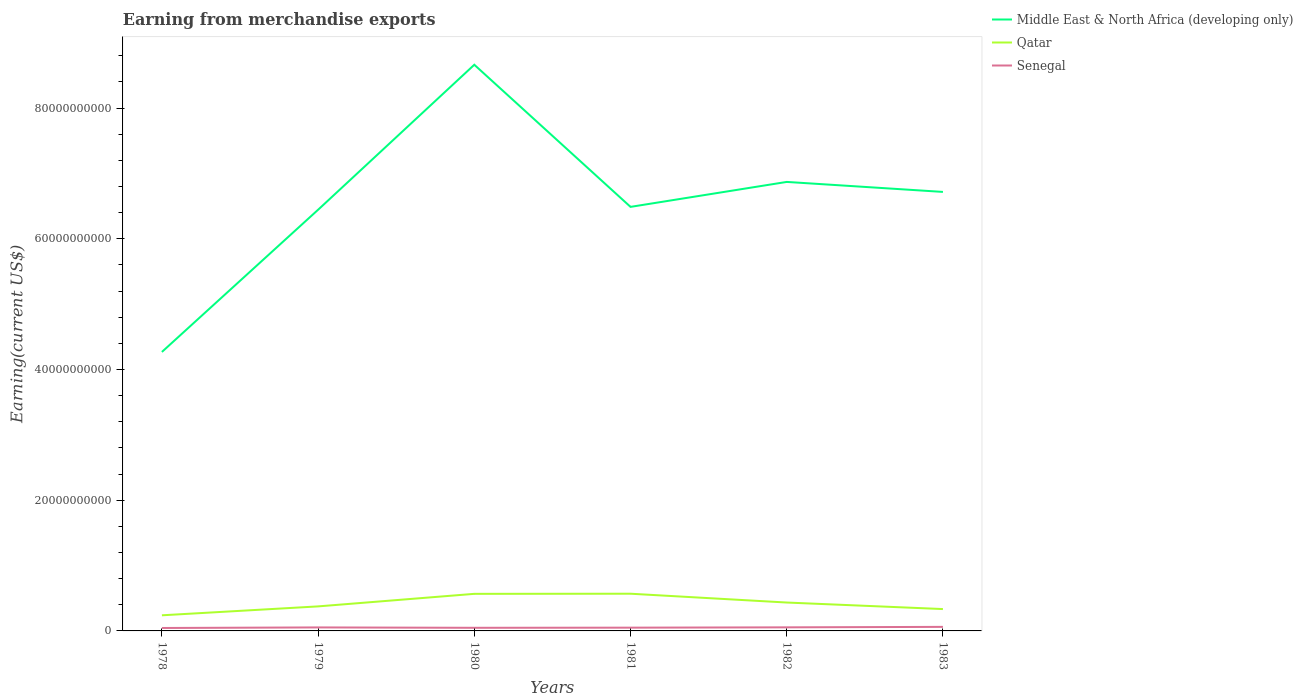How many different coloured lines are there?
Provide a succinct answer. 3. Across all years, what is the maximum amount earned from merchandise exports in Senegal?
Your response must be concise. 4.49e+08. In which year was the amount earned from merchandise exports in Qatar maximum?
Give a very brief answer. 1978. What is the total amount earned from merchandise exports in Qatar in the graph?
Make the answer very short. 9.98e+08. What is the difference between the highest and the second highest amount earned from merchandise exports in Middle East & North Africa (developing only)?
Offer a very short reply. 4.39e+1. How many years are there in the graph?
Make the answer very short. 6. Does the graph contain grids?
Your answer should be very brief. No. How many legend labels are there?
Offer a terse response. 3. What is the title of the graph?
Your response must be concise. Earning from merchandise exports. Does "Comoros" appear as one of the legend labels in the graph?
Keep it short and to the point. No. What is the label or title of the X-axis?
Offer a terse response. Years. What is the label or title of the Y-axis?
Give a very brief answer. Earning(current US$). What is the Earning(current US$) in Middle East & North Africa (developing only) in 1978?
Provide a succinct answer. 4.27e+1. What is the Earning(current US$) of Qatar in 1978?
Your answer should be compact. 2.39e+09. What is the Earning(current US$) in Senegal in 1978?
Your answer should be compact. 4.49e+08. What is the Earning(current US$) of Middle East & North Africa (developing only) in 1979?
Provide a succinct answer. 6.44e+1. What is the Earning(current US$) in Qatar in 1979?
Provide a short and direct response. 3.75e+09. What is the Earning(current US$) of Senegal in 1979?
Offer a very short reply. 5.35e+08. What is the Earning(current US$) of Middle East & North Africa (developing only) in 1980?
Your answer should be very brief. 8.66e+1. What is the Earning(current US$) in Qatar in 1980?
Ensure brevity in your answer.  5.67e+09. What is the Earning(current US$) of Senegal in 1980?
Give a very brief answer. 4.77e+08. What is the Earning(current US$) in Middle East & North Africa (developing only) in 1981?
Make the answer very short. 6.49e+1. What is the Earning(current US$) of Qatar in 1981?
Provide a succinct answer. 5.69e+09. What is the Earning(current US$) of Senegal in 1981?
Keep it short and to the point. 5.00e+08. What is the Earning(current US$) of Middle East & North Africa (developing only) in 1982?
Provide a short and direct response. 6.87e+1. What is the Earning(current US$) in Qatar in 1982?
Offer a terse response. 4.34e+09. What is the Earning(current US$) in Senegal in 1982?
Offer a terse response. 5.48e+08. What is the Earning(current US$) of Middle East & North Africa (developing only) in 1983?
Offer a terse response. 6.72e+1. What is the Earning(current US$) of Qatar in 1983?
Your response must be concise. 3.34e+09. What is the Earning(current US$) in Senegal in 1983?
Ensure brevity in your answer.  6.18e+08. Across all years, what is the maximum Earning(current US$) in Middle East & North Africa (developing only)?
Your answer should be very brief. 8.66e+1. Across all years, what is the maximum Earning(current US$) of Qatar?
Ensure brevity in your answer.  5.69e+09. Across all years, what is the maximum Earning(current US$) in Senegal?
Your answer should be very brief. 6.18e+08. Across all years, what is the minimum Earning(current US$) in Middle East & North Africa (developing only)?
Give a very brief answer. 4.27e+1. Across all years, what is the minimum Earning(current US$) of Qatar?
Provide a short and direct response. 2.39e+09. Across all years, what is the minimum Earning(current US$) of Senegal?
Provide a short and direct response. 4.49e+08. What is the total Earning(current US$) in Middle East & North Africa (developing only) in the graph?
Offer a very short reply. 3.94e+11. What is the total Earning(current US$) of Qatar in the graph?
Make the answer very short. 2.52e+1. What is the total Earning(current US$) in Senegal in the graph?
Your answer should be compact. 3.13e+09. What is the difference between the Earning(current US$) of Middle East & North Africa (developing only) in 1978 and that in 1979?
Keep it short and to the point. -2.18e+1. What is the difference between the Earning(current US$) of Qatar in 1978 and that in 1979?
Keep it short and to the point. -1.36e+09. What is the difference between the Earning(current US$) in Senegal in 1978 and that in 1979?
Provide a succinct answer. -8.59e+07. What is the difference between the Earning(current US$) in Middle East & North Africa (developing only) in 1978 and that in 1980?
Your response must be concise. -4.39e+1. What is the difference between the Earning(current US$) of Qatar in 1978 and that in 1980?
Your answer should be very brief. -3.28e+09. What is the difference between the Earning(current US$) in Senegal in 1978 and that in 1980?
Make the answer very short. -2.76e+07. What is the difference between the Earning(current US$) of Middle East & North Africa (developing only) in 1978 and that in 1981?
Keep it short and to the point. -2.22e+1. What is the difference between the Earning(current US$) of Qatar in 1978 and that in 1981?
Offer a terse response. -3.30e+09. What is the difference between the Earning(current US$) in Senegal in 1978 and that in 1981?
Give a very brief answer. -5.06e+07. What is the difference between the Earning(current US$) of Middle East & North Africa (developing only) in 1978 and that in 1982?
Give a very brief answer. -2.60e+1. What is the difference between the Earning(current US$) of Qatar in 1978 and that in 1982?
Your answer should be compact. -1.95e+09. What is the difference between the Earning(current US$) in Senegal in 1978 and that in 1982?
Offer a very short reply. -9.86e+07. What is the difference between the Earning(current US$) in Middle East & North Africa (developing only) in 1978 and that in 1983?
Make the answer very short. -2.45e+1. What is the difference between the Earning(current US$) of Qatar in 1978 and that in 1983?
Offer a terse response. -9.54e+08. What is the difference between the Earning(current US$) in Senegal in 1978 and that in 1983?
Your answer should be compact. -1.69e+08. What is the difference between the Earning(current US$) of Middle East & North Africa (developing only) in 1979 and that in 1980?
Offer a terse response. -2.22e+1. What is the difference between the Earning(current US$) in Qatar in 1979 and that in 1980?
Provide a short and direct response. -1.92e+09. What is the difference between the Earning(current US$) in Senegal in 1979 and that in 1980?
Give a very brief answer. 5.83e+07. What is the difference between the Earning(current US$) in Middle East & North Africa (developing only) in 1979 and that in 1981?
Offer a very short reply. -4.37e+08. What is the difference between the Earning(current US$) of Qatar in 1979 and that in 1981?
Ensure brevity in your answer.  -1.94e+09. What is the difference between the Earning(current US$) in Senegal in 1979 and that in 1981?
Provide a succinct answer. 3.53e+07. What is the difference between the Earning(current US$) in Middle East & North Africa (developing only) in 1979 and that in 1982?
Offer a very short reply. -4.26e+09. What is the difference between the Earning(current US$) in Qatar in 1979 and that in 1982?
Provide a short and direct response. -5.90e+08. What is the difference between the Earning(current US$) of Senegal in 1979 and that in 1982?
Make the answer very short. -1.27e+07. What is the difference between the Earning(current US$) of Middle East & North Africa (developing only) in 1979 and that in 1983?
Your answer should be very brief. -2.73e+09. What is the difference between the Earning(current US$) of Qatar in 1979 and that in 1983?
Keep it short and to the point. 4.08e+08. What is the difference between the Earning(current US$) of Senegal in 1979 and that in 1983?
Provide a succinct answer. -8.27e+07. What is the difference between the Earning(current US$) of Middle East & North Africa (developing only) in 1980 and that in 1981?
Provide a short and direct response. 2.17e+1. What is the difference between the Earning(current US$) of Qatar in 1980 and that in 1981?
Give a very brief answer. -1.90e+07. What is the difference between the Earning(current US$) in Senegal in 1980 and that in 1981?
Offer a very short reply. -2.30e+07. What is the difference between the Earning(current US$) in Middle East & North Africa (developing only) in 1980 and that in 1982?
Give a very brief answer. 1.79e+1. What is the difference between the Earning(current US$) in Qatar in 1980 and that in 1982?
Give a very brief answer. 1.33e+09. What is the difference between the Earning(current US$) of Senegal in 1980 and that in 1982?
Keep it short and to the point. -7.10e+07. What is the difference between the Earning(current US$) of Middle East & North Africa (developing only) in 1980 and that in 1983?
Your answer should be compact. 1.95e+1. What is the difference between the Earning(current US$) in Qatar in 1980 and that in 1983?
Your answer should be compact. 2.33e+09. What is the difference between the Earning(current US$) in Senegal in 1980 and that in 1983?
Provide a succinct answer. -1.41e+08. What is the difference between the Earning(current US$) of Middle East & North Africa (developing only) in 1981 and that in 1982?
Provide a short and direct response. -3.82e+09. What is the difference between the Earning(current US$) of Qatar in 1981 and that in 1982?
Your answer should be very brief. 1.35e+09. What is the difference between the Earning(current US$) of Senegal in 1981 and that in 1982?
Provide a short and direct response. -4.80e+07. What is the difference between the Earning(current US$) of Middle East & North Africa (developing only) in 1981 and that in 1983?
Provide a succinct answer. -2.29e+09. What is the difference between the Earning(current US$) of Qatar in 1981 and that in 1983?
Make the answer very short. 2.35e+09. What is the difference between the Earning(current US$) of Senegal in 1981 and that in 1983?
Provide a succinct answer. -1.18e+08. What is the difference between the Earning(current US$) in Middle East & North Africa (developing only) in 1982 and that in 1983?
Ensure brevity in your answer.  1.53e+09. What is the difference between the Earning(current US$) in Qatar in 1982 and that in 1983?
Provide a succinct answer. 9.98e+08. What is the difference between the Earning(current US$) of Senegal in 1982 and that in 1983?
Your answer should be very brief. -7.00e+07. What is the difference between the Earning(current US$) of Middle East & North Africa (developing only) in 1978 and the Earning(current US$) of Qatar in 1979?
Your answer should be very brief. 3.89e+1. What is the difference between the Earning(current US$) in Middle East & North Africa (developing only) in 1978 and the Earning(current US$) in Senegal in 1979?
Provide a succinct answer. 4.21e+1. What is the difference between the Earning(current US$) in Qatar in 1978 and the Earning(current US$) in Senegal in 1979?
Keep it short and to the point. 1.86e+09. What is the difference between the Earning(current US$) in Middle East & North Africa (developing only) in 1978 and the Earning(current US$) in Qatar in 1980?
Offer a very short reply. 3.70e+1. What is the difference between the Earning(current US$) in Middle East & North Africa (developing only) in 1978 and the Earning(current US$) in Senegal in 1980?
Offer a terse response. 4.22e+1. What is the difference between the Earning(current US$) in Qatar in 1978 and the Earning(current US$) in Senegal in 1980?
Give a very brief answer. 1.91e+09. What is the difference between the Earning(current US$) of Middle East & North Africa (developing only) in 1978 and the Earning(current US$) of Qatar in 1981?
Ensure brevity in your answer.  3.70e+1. What is the difference between the Earning(current US$) of Middle East & North Africa (developing only) in 1978 and the Earning(current US$) of Senegal in 1981?
Offer a terse response. 4.22e+1. What is the difference between the Earning(current US$) in Qatar in 1978 and the Earning(current US$) in Senegal in 1981?
Provide a short and direct response. 1.89e+09. What is the difference between the Earning(current US$) of Middle East & North Africa (developing only) in 1978 and the Earning(current US$) of Qatar in 1982?
Offer a terse response. 3.83e+1. What is the difference between the Earning(current US$) of Middle East & North Africa (developing only) in 1978 and the Earning(current US$) of Senegal in 1982?
Give a very brief answer. 4.21e+1. What is the difference between the Earning(current US$) of Qatar in 1978 and the Earning(current US$) of Senegal in 1982?
Give a very brief answer. 1.84e+09. What is the difference between the Earning(current US$) of Middle East & North Africa (developing only) in 1978 and the Earning(current US$) of Qatar in 1983?
Ensure brevity in your answer.  3.93e+1. What is the difference between the Earning(current US$) in Middle East & North Africa (developing only) in 1978 and the Earning(current US$) in Senegal in 1983?
Ensure brevity in your answer.  4.21e+1. What is the difference between the Earning(current US$) of Qatar in 1978 and the Earning(current US$) of Senegal in 1983?
Offer a terse response. 1.77e+09. What is the difference between the Earning(current US$) of Middle East & North Africa (developing only) in 1979 and the Earning(current US$) of Qatar in 1980?
Keep it short and to the point. 5.88e+1. What is the difference between the Earning(current US$) in Middle East & North Africa (developing only) in 1979 and the Earning(current US$) in Senegal in 1980?
Your response must be concise. 6.40e+1. What is the difference between the Earning(current US$) in Qatar in 1979 and the Earning(current US$) in Senegal in 1980?
Offer a very short reply. 3.28e+09. What is the difference between the Earning(current US$) of Middle East & North Africa (developing only) in 1979 and the Earning(current US$) of Qatar in 1981?
Offer a terse response. 5.87e+1. What is the difference between the Earning(current US$) of Middle East & North Africa (developing only) in 1979 and the Earning(current US$) of Senegal in 1981?
Your response must be concise. 6.39e+1. What is the difference between the Earning(current US$) in Qatar in 1979 and the Earning(current US$) in Senegal in 1981?
Make the answer very short. 3.25e+09. What is the difference between the Earning(current US$) of Middle East & North Africa (developing only) in 1979 and the Earning(current US$) of Qatar in 1982?
Offer a very short reply. 6.01e+1. What is the difference between the Earning(current US$) in Middle East & North Africa (developing only) in 1979 and the Earning(current US$) in Senegal in 1982?
Offer a terse response. 6.39e+1. What is the difference between the Earning(current US$) of Qatar in 1979 and the Earning(current US$) of Senegal in 1982?
Offer a very short reply. 3.20e+09. What is the difference between the Earning(current US$) of Middle East & North Africa (developing only) in 1979 and the Earning(current US$) of Qatar in 1983?
Give a very brief answer. 6.11e+1. What is the difference between the Earning(current US$) of Middle East & North Africa (developing only) in 1979 and the Earning(current US$) of Senegal in 1983?
Your answer should be compact. 6.38e+1. What is the difference between the Earning(current US$) in Qatar in 1979 and the Earning(current US$) in Senegal in 1983?
Offer a terse response. 3.13e+09. What is the difference between the Earning(current US$) in Middle East & North Africa (developing only) in 1980 and the Earning(current US$) in Qatar in 1981?
Ensure brevity in your answer.  8.09e+1. What is the difference between the Earning(current US$) in Middle East & North Africa (developing only) in 1980 and the Earning(current US$) in Senegal in 1981?
Give a very brief answer. 8.61e+1. What is the difference between the Earning(current US$) in Qatar in 1980 and the Earning(current US$) in Senegal in 1981?
Your answer should be very brief. 5.17e+09. What is the difference between the Earning(current US$) of Middle East & North Africa (developing only) in 1980 and the Earning(current US$) of Qatar in 1982?
Provide a succinct answer. 8.23e+1. What is the difference between the Earning(current US$) of Middle East & North Africa (developing only) in 1980 and the Earning(current US$) of Senegal in 1982?
Your answer should be compact. 8.61e+1. What is the difference between the Earning(current US$) in Qatar in 1980 and the Earning(current US$) in Senegal in 1982?
Your answer should be very brief. 5.12e+09. What is the difference between the Earning(current US$) of Middle East & North Africa (developing only) in 1980 and the Earning(current US$) of Qatar in 1983?
Keep it short and to the point. 8.33e+1. What is the difference between the Earning(current US$) in Middle East & North Africa (developing only) in 1980 and the Earning(current US$) in Senegal in 1983?
Provide a short and direct response. 8.60e+1. What is the difference between the Earning(current US$) in Qatar in 1980 and the Earning(current US$) in Senegal in 1983?
Your response must be concise. 5.05e+09. What is the difference between the Earning(current US$) in Middle East & North Africa (developing only) in 1981 and the Earning(current US$) in Qatar in 1982?
Your answer should be compact. 6.05e+1. What is the difference between the Earning(current US$) in Middle East & North Africa (developing only) in 1981 and the Earning(current US$) in Senegal in 1982?
Offer a very short reply. 6.43e+1. What is the difference between the Earning(current US$) in Qatar in 1981 and the Earning(current US$) in Senegal in 1982?
Your answer should be compact. 5.14e+09. What is the difference between the Earning(current US$) in Middle East & North Africa (developing only) in 1981 and the Earning(current US$) in Qatar in 1983?
Keep it short and to the point. 6.15e+1. What is the difference between the Earning(current US$) in Middle East & North Africa (developing only) in 1981 and the Earning(current US$) in Senegal in 1983?
Keep it short and to the point. 6.43e+1. What is the difference between the Earning(current US$) in Qatar in 1981 and the Earning(current US$) in Senegal in 1983?
Offer a very short reply. 5.07e+09. What is the difference between the Earning(current US$) in Middle East & North Africa (developing only) in 1982 and the Earning(current US$) in Qatar in 1983?
Provide a succinct answer. 6.53e+1. What is the difference between the Earning(current US$) in Middle East & North Africa (developing only) in 1982 and the Earning(current US$) in Senegal in 1983?
Keep it short and to the point. 6.81e+1. What is the difference between the Earning(current US$) in Qatar in 1982 and the Earning(current US$) in Senegal in 1983?
Your response must be concise. 3.72e+09. What is the average Earning(current US$) in Middle East & North Africa (developing only) per year?
Your response must be concise. 6.57e+1. What is the average Earning(current US$) in Qatar per year?
Provide a succinct answer. 4.20e+09. What is the average Earning(current US$) in Senegal per year?
Keep it short and to the point. 5.21e+08. In the year 1978, what is the difference between the Earning(current US$) of Middle East & North Africa (developing only) and Earning(current US$) of Qatar?
Offer a terse response. 4.03e+1. In the year 1978, what is the difference between the Earning(current US$) of Middle East & North Africa (developing only) and Earning(current US$) of Senegal?
Your answer should be very brief. 4.22e+1. In the year 1978, what is the difference between the Earning(current US$) of Qatar and Earning(current US$) of Senegal?
Offer a very short reply. 1.94e+09. In the year 1979, what is the difference between the Earning(current US$) of Middle East & North Africa (developing only) and Earning(current US$) of Qatar?
Offer a very short reply. 6.07e+1. In the year 1979, what is the difference between the Earning(current US$) of Middle East & North Africa (developing only) and Earning(current US$) of Senegal?
Offer a very short reply. 6.39e+1. In the year 1979, what is the difference between the Earning(current US$) in Qatar and Earning(current US$) in Senegal?
Your answer should be very brief. 3.22e+09. In the year 1980, what is the difference between the Earning(current US$) in Middle East & North Africa (developing only) and Earning(current US$) in Qatar?
Ensure brevity in your answer.  8.09e+1. In the year 1980, what is the difference between the Earning(current US$) in Middle East & North Africa (developing only) and Earning(current US$) in Senegal?
Provide a short and direct response. 8.61e+1. In the year 1980, what is the difference between the Earning(current US$) of Qatar and Earning(current US$) of Senegal?
Provide a short and direct response. 5.20e+09. In the year 1981, what is the difference between the Earning(current US$) of Middle East & North Africa (developing only) and Earning(current US$) of Qatar?
Provide a short and direct response. 5.92e+1. In the year 1981, what is the difference between the Earning(current US$) of Middle East & North Africa (developing only) and Earning(current US$) of Senegal?
Provide a short and direct response. 6.44e+1. In the year 1981, what is the difference between the Earning(current US$) of Qatar and Earning(current US$) of Senegal?
Provide a succinct answer. 5.19e+09. In the year 1982, what is the difference between the Earning(current US$) in Middle East & North Africa (developing only) and Earning(current US$) in Qatar?
Provide a succinct answer. 6.43e+1. In the year 1982, what is the difference between the Earning(current US$) in Middle East & North Africa (developing only) and Earning(current US$) in Senegal?
Your response must be concise. 6.81e+1. In the year 1982, what is the difference between the Earning(current US$) in Qatar and Earning(current US$) in Senegal?
Make the answer very short. 3.80e+09. In the year 1983, what is the difference between the Earning(current US$) in Middle East & North Africa (developing only) and Earning(current US$) in Qatar?
Provide a short and direct response. 6.38e+1. In the year 1983, what is the difference between the Earning(current US$) of Middle East & North Africa (developing only) and Earning(current US$) of Senegal?
Your answer should be very brief. 6.65e+1. In the year 1983, what is the difference between the Earning(current US$) of Qatar and Earning(current US$) of Senegal?
Offer a terse response. 2.73e+09. What is the ratio of the Earning(current US$) of Middle East & North Africa (developing only) in 1978 to that in 1979?
Offer a terse response. 0.66. What is the ratio of the Earning(current US$) of Qatar in 1978 to that in 1979?
Provide a short and direct response. 0.64. What is the ratio of the Earning(current US$) in Senegal in 1978 to that in 1979?
Your response must be concise. 0.84. What is the ratio of the Earning(current US$) in Middle East & North Africa (developing only) in 1978 to that in 1980?
Make the answer very short. 0.49. What is the ratio of the Earning(current US$) of Qatar in 1978 to that in 1980?
Ensure brevity in your answer.  0.42. What is the ratio of the Earning(current US$) in Senegal in 1978 to that in 1980?
Provide a succinct answer. 0.94. What is the ratio of the Earning(current US$) in Middle East & North Africa (developing only) in 1978 to that in 1981?
Give a very brief answer. 0.66. What is the ratio of the Earning(current US$) of Qatar in 1978 to that in 1981?
Your answer should be compact. 0.42. What is the ratio of the Earning(current US$) of Senegal in 1978 to that in 1981?
Keep it short and to the point. 0.9. What is the ratio of the Earning(current US$) in Middle East & North Africa (developing only) in 1978 to that in 1982?
Your response must be concise. 0.62. What is the ratio of the Earning(current US$) of Qatar in 1978 to that in 1982?
Keep it short and to the point. 0.55. What is the ratio of the Earning(current US$) of Senegal in 1978 to that in 1982?
Keep it short and to the point. 0.82. What is the ratio of the Earning(current US$) in Middle East & North Africa (developing only) in 1978 to that in 1983?
Provide a succinct answer. 0.64. What is the ratio of the Earning(current US$) in Qatar in 1978 to that in 1983?
Ensure brevity in your answer.  0.71. What is the ratio of the Earning(current US$) of Senegal in 1978 to that in 1983?
Keep it short and to the point. 0.73. What is the ratio of the Earning(current US$) in Middle East & North Africa (developing only) in 1979 to that in 1980?
Keep it short and to the point. 0.74. What is the ratio of the Earning(current US$) in Qatar in 1979 to that in 1980?
Offer a very short reply. 0.66. What is the ratio of the Earning(current US$) of Senegal in 1979 to that in 1980?
Offer a terse response. 1.12. What is the ratio of the Earning(current US$) in Middle East & North Africa (developing only) in 1979 to that in 1981?
Ensure brevity in your answer.  0.99. What is the ratio of the Earning(current US$) of Qatar in 1979 to that in 1981?
Provide a short and direct response. 0.66. What is the ratio of the Earning(current US$) in Senegal in 1979 to that in 1981?
Your answer should be very brief. 1.07. What is the ratio of the Earning(current US$) of Middle East & North Africa (developing only) in 1979 to that in 1982?
Give a very brief answer. 0.94. What is the ratio of the Earning(current US$) of Qatar in 1979 to that in 1982?
Offer a terse response. 0.86. What is the ratio of the Earning(current US$) of Senegal in 1979 to that in 1982?
Your response must be concise. 0.98. What is the ratio of the Earning(current US$) in Middle East & North Africa (developing only) in 1979 to that in 1983?
Ensure brevity in your answer.  0.96. What is the ratio of the Earning(current US$) of Qatar in 1979 to that in 1983?
Offer a very short reply. 1.12. What is the ratio of the Earning(current US$) of Senegal in 1979 to that in 1983?
Provide a succinct answer. 0.87. What is the ratio of the Earning(current US$) in Middle East & North Africa (developing only) in 1980 to that in 1981?
Your response must be concise. 1.34. What is the ratio of the Earning(current US$) of Qatar in 1980 to that in 1981?
Give a very brief answer. 1. What is the ratio of the Earning(current US$) of Senegal in 1980 to that in 1981?
Give a very brief answer. 0.95. What is the ratio of the Earning(current US$) of Middle East & North Africa (developing only) in 1980 to that in 1982?
Offer a very short reply. 1.26. What is the ratio of the Earning(current US$) in Qatar in 1980 to that in 1982?
Make the answer very short. 1.31. What is the ratio of the Earning(current US$) in Senegal in 1980 to that in 1982?
Your answer should be very brief. 0.87. What is the ratio of the Earning(current US$) of Middle East & North Africa (developing only) in 1980 to that in 1983?
Your answer should be very brief. 1.29. What is the ratio of the Earning(current US$) of Qatar in 1980 to that in 1983?
Provide a short and direct response. 1.7. What is the ratio of the Earning(current US$) in Senegal in 1980 to that in 1983?
Your response must be concise. 0.77. What is the ratio of the Earning(current US$) in Qatar in 1981 to that in 1982?
Provide a short and direct response. 1.31. What is the ratio of the Earning(current US$) of Senegal in 1981 to that in 1982?
Make the answer very short. 0.91. What is the ratio of the Earning(current US$) in Middle East & North Africa (developing only) in 1981 to that in 1983?
Provide a short and direct response. 0.97. What is the ratio of the Earning(current US$) of Qatar in 1981 to that in 1983?
Your response must be concise. 1.7. What is the ratio of the Earning(current US$) of Senegal in 1981 to that in 1983?
Your answer should be very brief. 0.81. What is the ratio of the Earning(current US$) in Middle East & North Africa (developing only) in 1982 to that in 1983?
Provide a succinct answer. 1.02. What is the ratio of the Earning(current US$) in Qatar in 1982 to that in 1983?
Keep it short and to the point. 1.3. What is the ratio of the Earning(current US$) of Senegal in 1982 to that in 1983?
Your response must be concise. 0.89. What is the difference between the highest and the second highest Earning(current US$) of Middle East & North Africa (developing only)?
Your answer should be very brief. 1.79e+1. What is the difference between the highest and the second highest Earning(current US$) of Qatar?
Your answer should be very brief. 1.90e+07. What is the difference between the highest and the second highest Earning(current US$) in Senegal?
Ensure brevity in your answer.  7.00e+07. What is the difference between the highest and the lowest Earning(current US$) of Middle East & North Africa (developing only)?
Your response must be concise. 4.39e+1. What is the difference between the highest and the lowest Earning(current US$) in Qatar?
Give a very brief answer. 3.30e+09. What is the difference between the highest and the lowest Earning(current US$) in Senegal?
Give a very brief answer. 1.69e+08. 